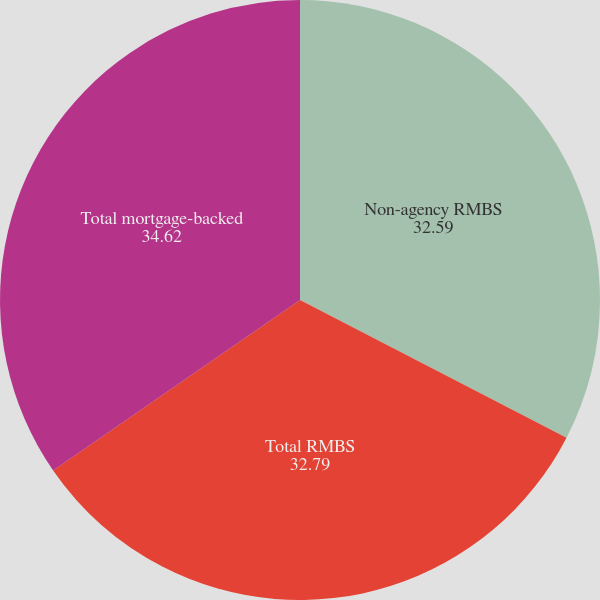Convert chart to OTSL. <chart><loc_0><loc_0><loc_500><loc_500><pie_chart><fcel>Non-agency RMBS<fcel>Total RMBS<fcel>Total mortgage-backed<nl><fcel>32.59%<fcel>32.79%<fcel>34.62%<nl></chart> 